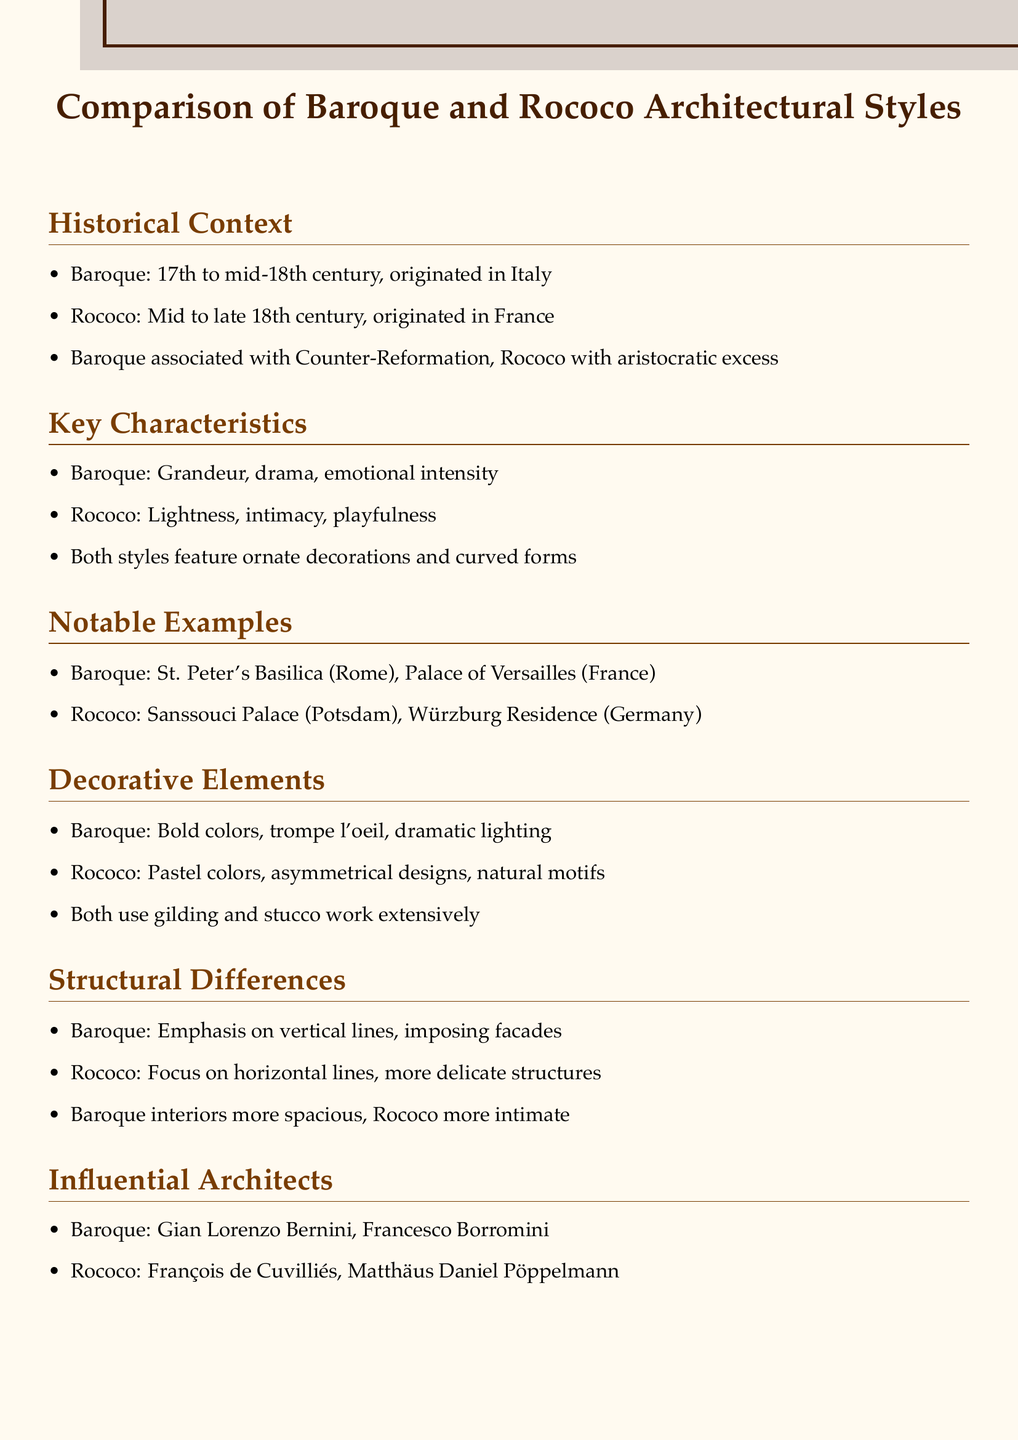What period does Baroque architecture cover? The period for Baroque architecture is stated as 17th to mid-18th century.
Answer: 17th to mid-18th century Where did Rococo architecture originate? The document mentions that Rococo originated in France.
Answer: France What is a key characteristic of Baroque architecture? The key characteristics for Baroque architecture include grandeur, drama, and emotional intensity.
Answer: Grandeur, drama, emotional intensity Which architect is associated with Rococo? The document lists François de Cuvilliés as an influential architect in the Rococo style.
Answer: François de Cuvilliés Name one notable example of Rococo architecture. The document provides examples of Rococo architecture including Sanssouci Palace.
Answer: Sanssouci Palace What kind of colors are used predominantly in Rococo design? According to the notes, Rococo design uses pastel colors.
Answer: Pastel colors Which historical event is Baroque architecture associated with? The notes specifically mention Baroque architecture's association with the Counter-Reformation.
Answer: Counter-Reformation What decorative element is common to both styles? The document specifies that gilding and stucco work are used extensively in both styles.
Answer: Gilding and stucco work 